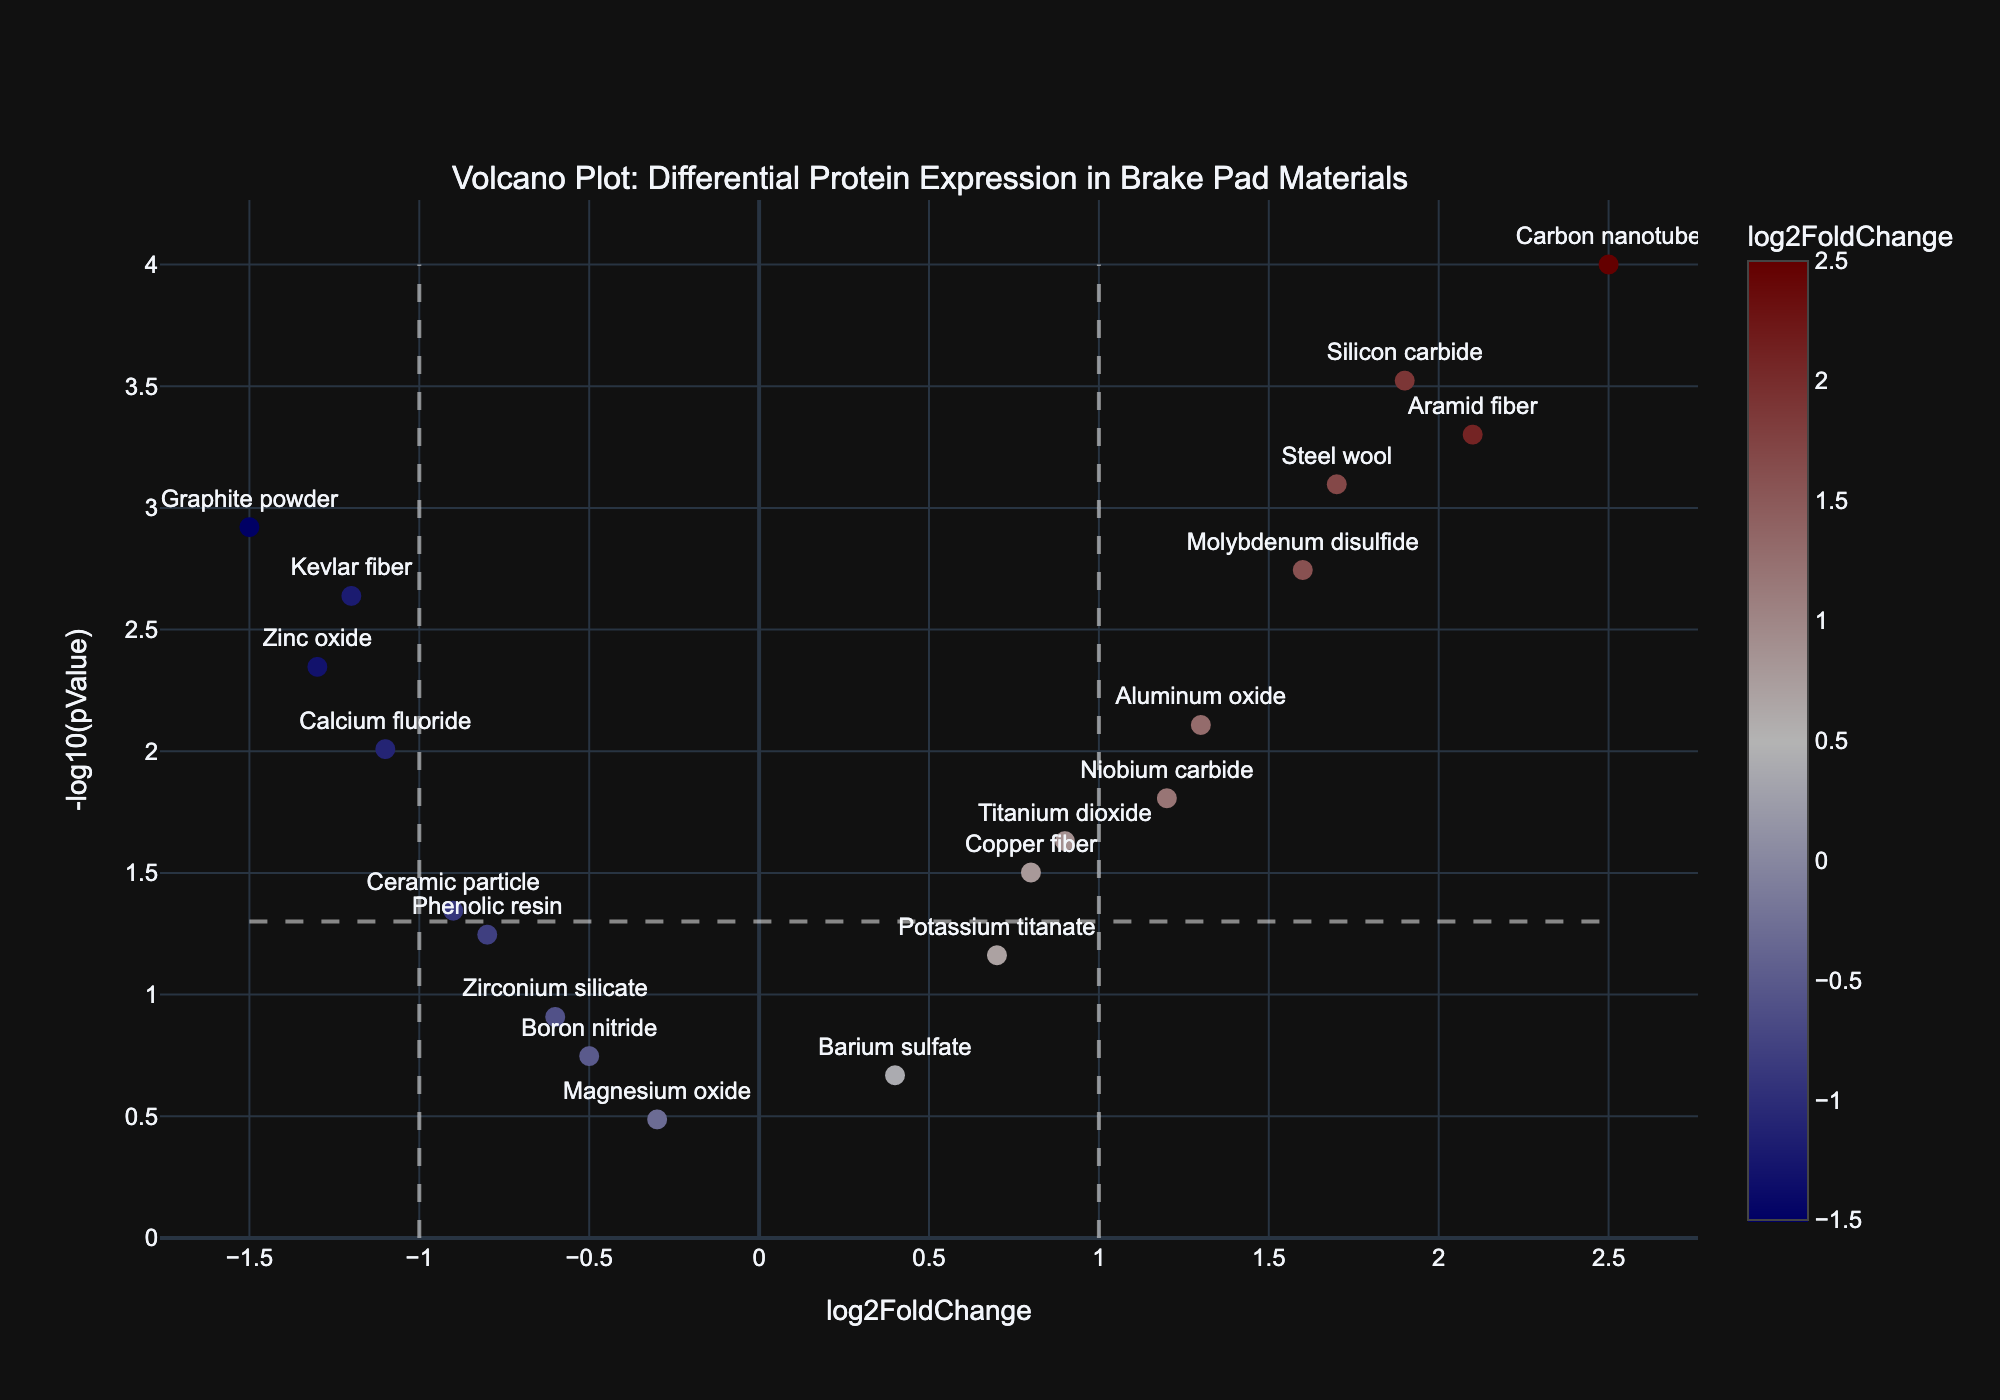What is the title of the figure? The title is often placed at the top of a plot and can be easily identified. Here, it indicates the main theme of the plot.
Answer: Volcano Plot: Differential Protein Expression in Brake Pad Materials How many data points are plotted in this figure? Each data point corresponds to a protein listed in the provided data. Counting the proteins gives the total number of data points.
Answer: 20 What does the X-axis represent? The X-axis typically has a label that describes the variable it represents. In this figure, it is labeled "log2FoldChange".
Answer: log2FoldChange Which protein has the highest -log10(pValue)? The highest -log10(pValue) corresponds to the maximum value on the Y-axis. By examining the Y-values or the hover information, we find the protein with the highest value.
Answer: Carbon nanotube What protein is associated with the highest positive log2FoldChange? The highest positive log2FoldChange will be the maximum value on the X-axis. By examining the X-values or the hover information, we find the protein with the highest positive log2FoldChange.
Answer: Carbon nanotube Which proteins fall within the standard threshold of significance (e.g., -log10(pValue) > 1.3) and have a log2FoldChange between -1 and 1? Proteins that meet these criteria can be identified by looking within the thresholds set by vertical and horizontal lines on the plot.
Answer: Copper fiber, Titanium dioxide, Niobium carbide Which two proteins have the most similar log2FoldChange values but differ significantly in their -log10(pValue) values? By comparing log2FoldChange values for similarity and then looking at their corresponding -log10(pValue) values, we can identify the pair.
Answer: Steel wool and Molybdenum disulfide How many proteins exhibit a negative log2FoldChange of less than -1 and meet the significance threshold? These proteins can be identified by finding those with log2FoldChange < -1 and -log10(pValue) > 1.3. Count the number of such proteins.
Answer: 2 (Graphite powder, Zinc oxide) Which protein shows the least significant change (largest pValue) and what is its log2FoldChange? The least significant change corresponds to the highest pValue, which can be examined by looking for the smallest -log10(pValue) value.
Answer: Magnesium oxide, -0.3 